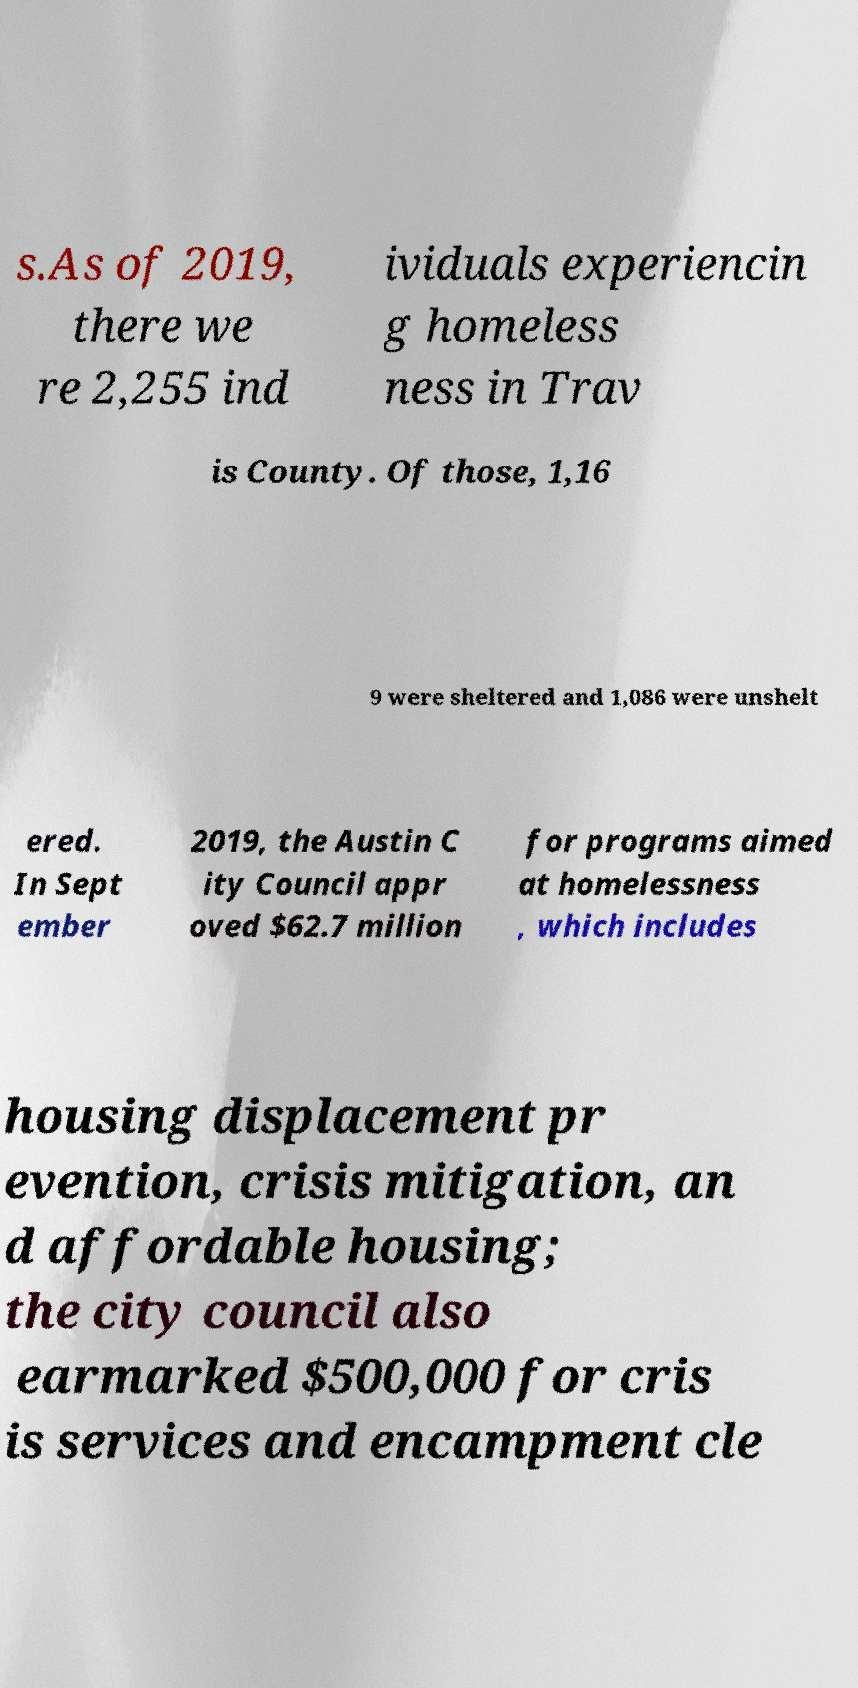For documentation purposes, I need the text within this image transcribed. Could you provide that? s.As of 2019, there we re 2,255 ind ividuals experiencin g homeless ness in Trav is County. Of those, 1,16 9 were sheltered and 1,086 were unshelt ered. In Sept ember 2019, the Austin C ity Council appr oved $62.7 million for programs aimed at homelessness , which includes housing displacement pr evention, crisis mitigation, an d affordable housing; the city council also earmarked $500,000 for cris is services and encampment cle 